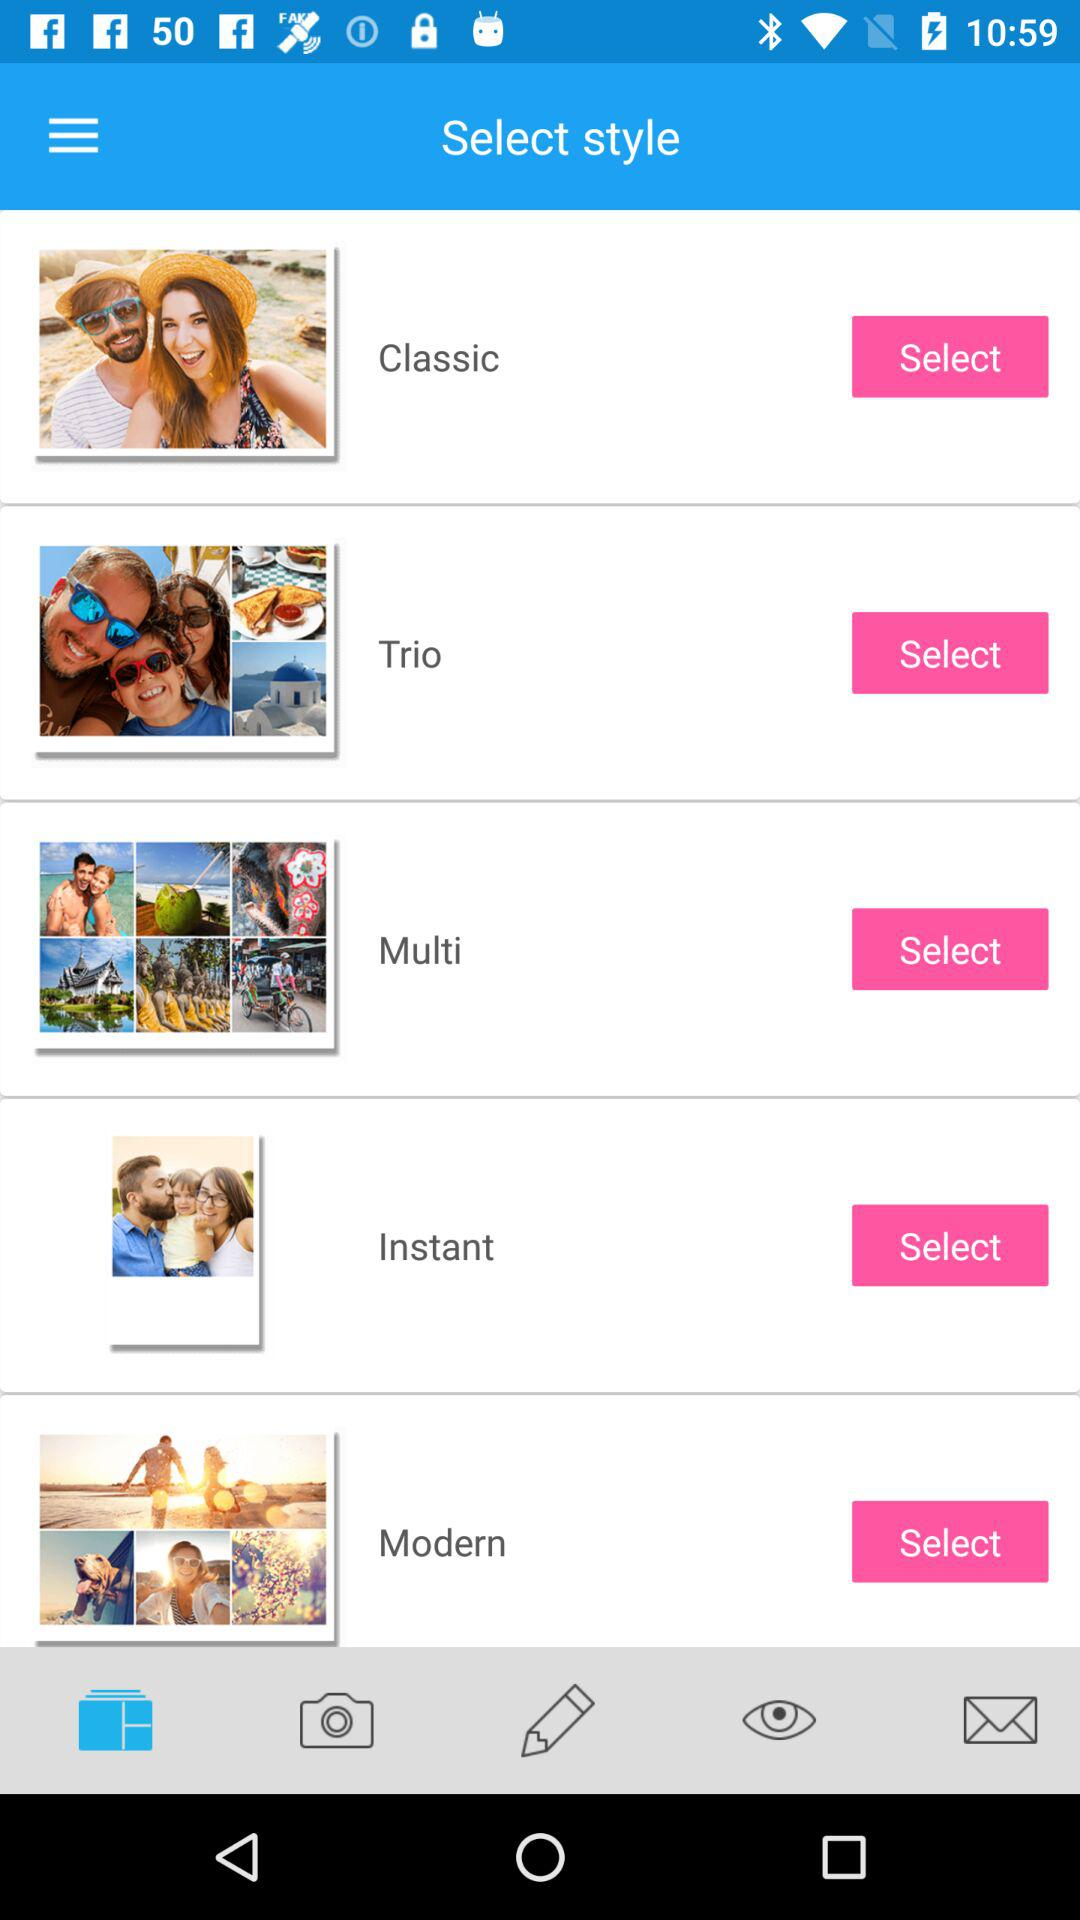Which style is selected?
When the provided information is insufficient, respond with <no answer>. <no answer> 